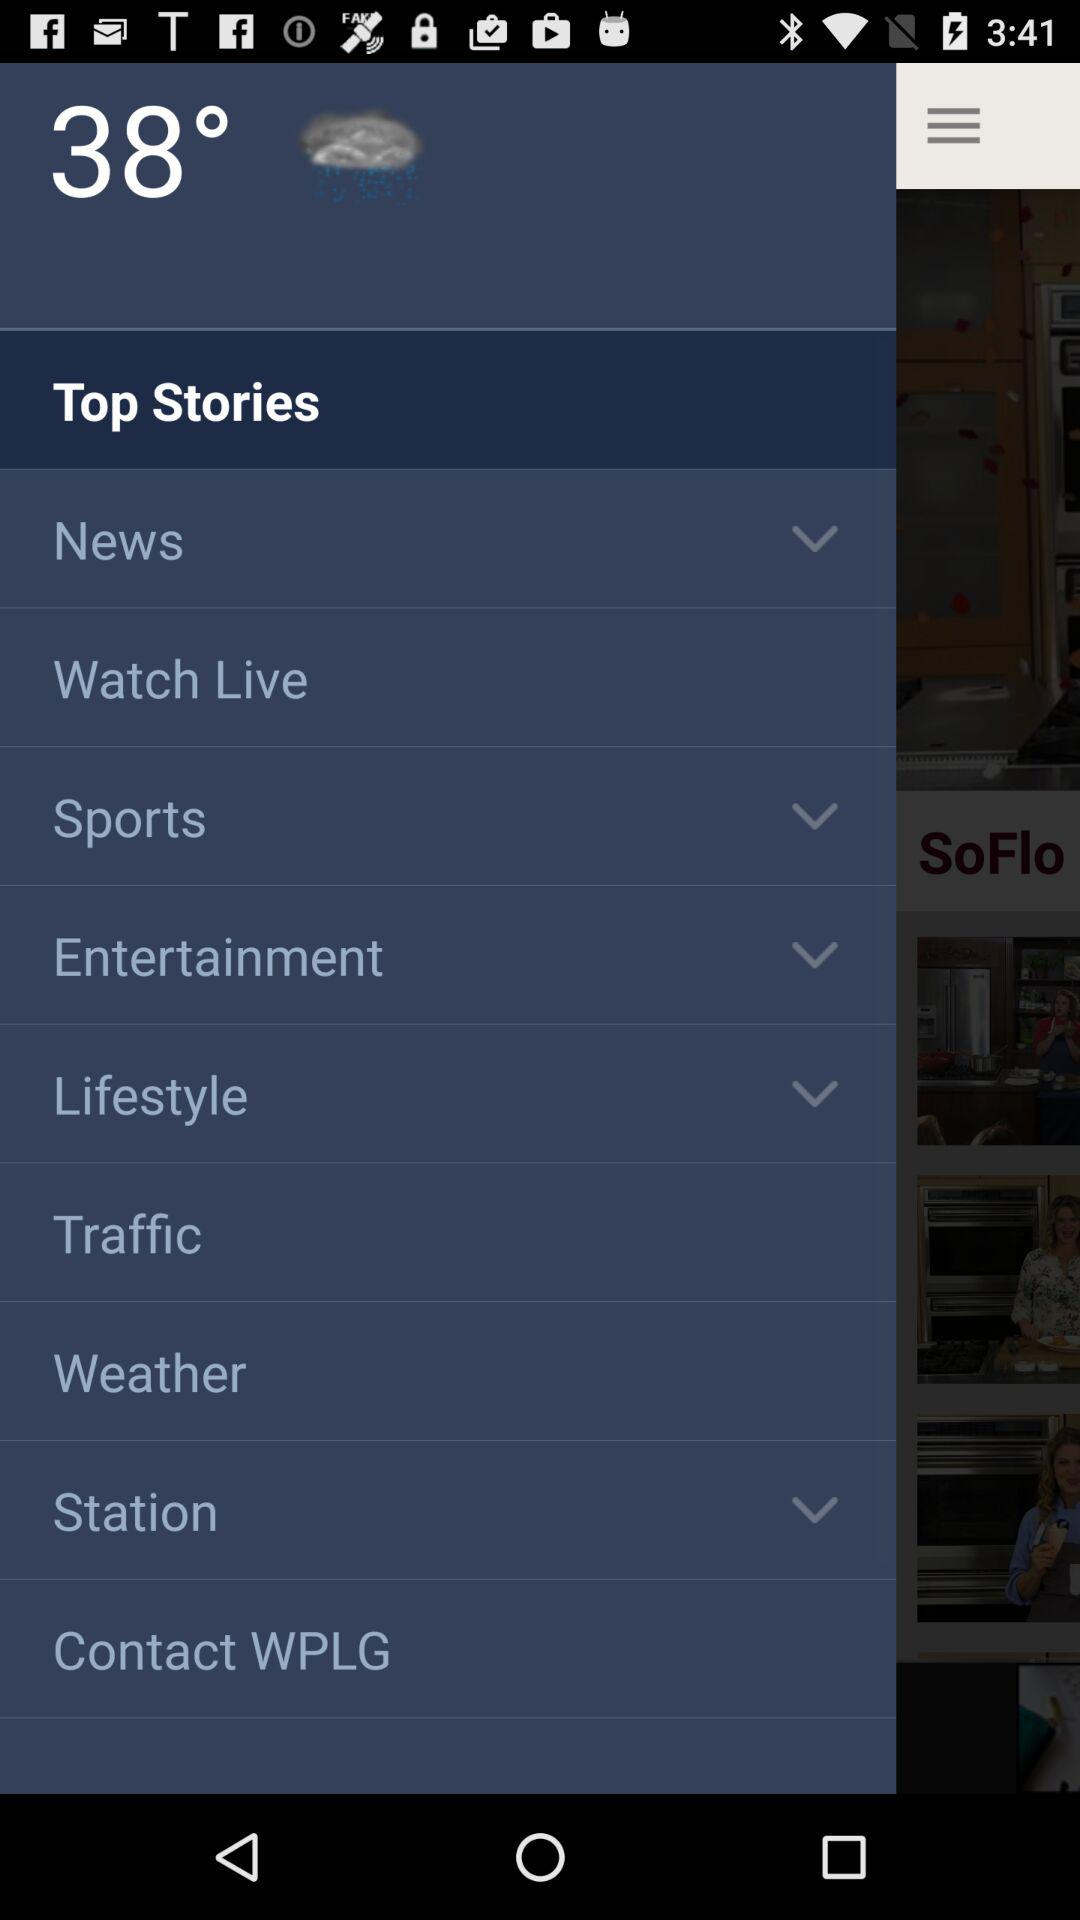What type of weather is there? The type of weather is rainy. 